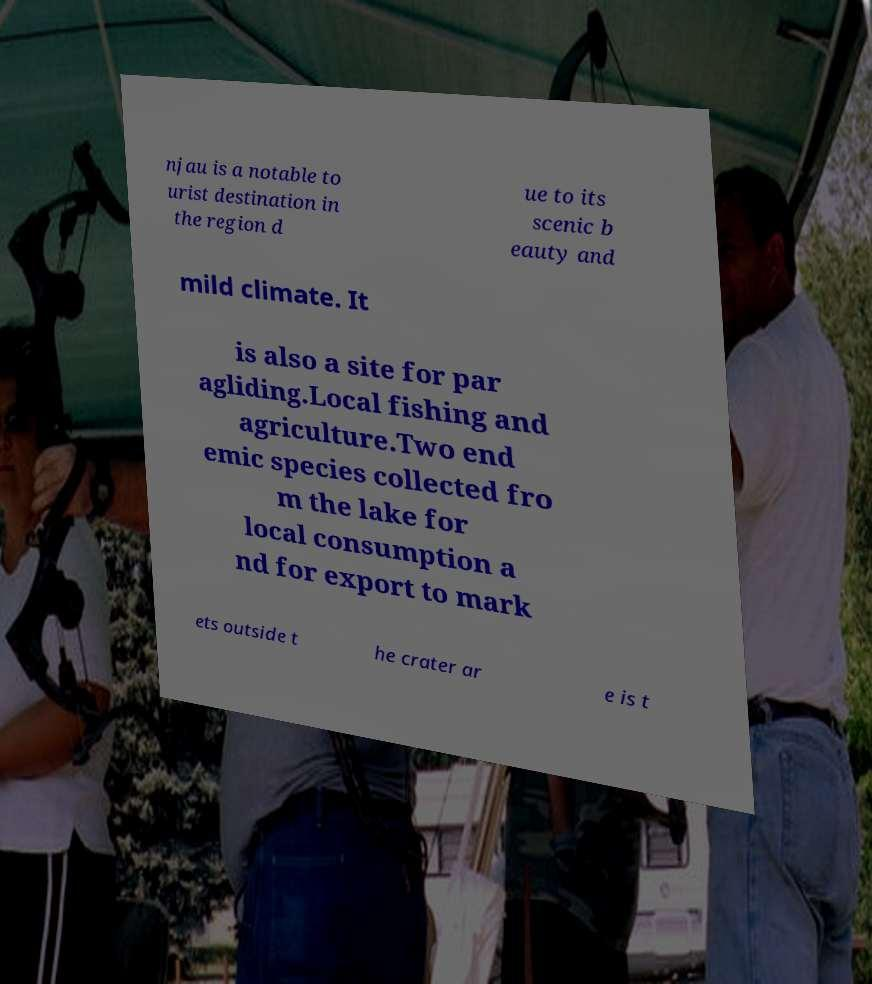For documentation purposes, I need the text within this image transcribed. Could you provide that? njau is a notable to urist destination in the region d ue to its scenic b eauty and mild climate. It is also a site for par agliding.Local fishing and agriculture.Two end emic species collected fro m the lake for local consumption a nd for export to mark ets outside t he crater ar e is t 